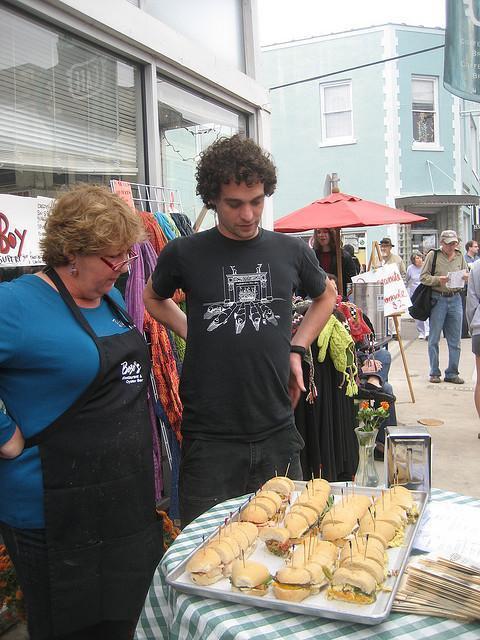What is the tray made from?
Make your selection from the four choices given to correctly answer the question.
Options: Wood, plastic, steel, glass. Steel. 